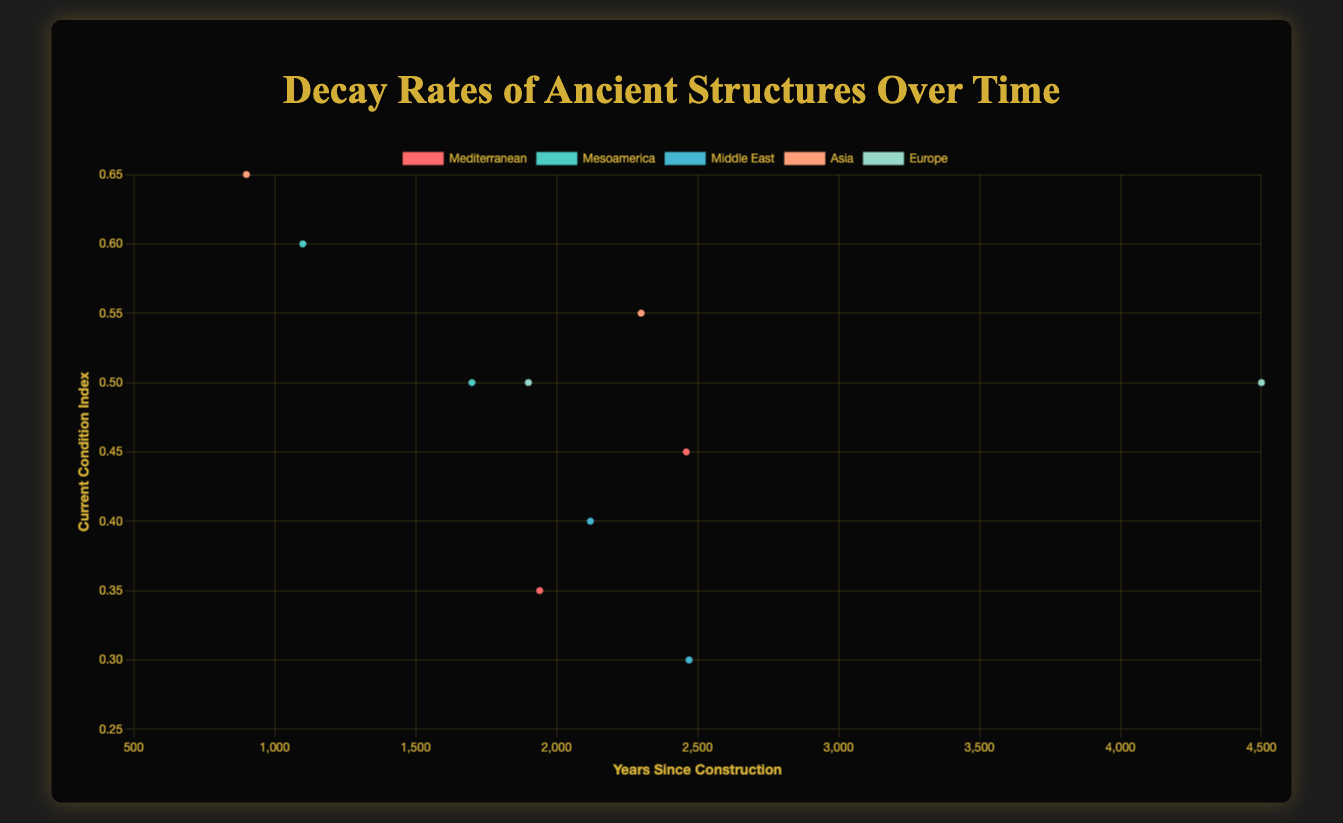Which region shows the lowest current condition index? Look for the region with the lowest value on the y-axis. The lowest condition index is 0.30, associated with Persepolis in the Middle East.
Answer: Middle East Which ancient structure has been standing the longest and what is its current condition index? Identify the data point farthest right on the x-axis, which represents the years since construction. Stonehenge in Europe has been standing for 4500 years with a current condition index of 0.50.
Answer: Stonehenge, 0.50 Which region has the highest average current condition index? Calculate the average condition index for each region by summing the condition indices of the structures within a region and dividing by the number of structures. The values are: Mediterranean (0.40), Mesoamerica (0.55), Middle East (0.35), Asia (0.60), and Europe (0.50). The highest average is in Asia.
Answer: Asia What is the difference in the current condition index between the Great Wall of China and Persepolis? Subtract the current condition index of Persepolis (0.30) from that of the Great Wall of China (0.55). The difference is 0.55 - 0.30 = 0.25.
Answer: 0.25 Is the condition index of Angkor Wat greater than that of Chichen Itza and if so, by how much? Compare the current condition index of Angkor Wat (0.65) with that of Chichen Itza (0.60). The difference is 0.65 - 0.60 = 0.05.
Answer: Yes, by 0.05 How does the current condition index of Parthenon compare to that of Colosseum? Compare the current condition indices of the Parthenon (0.45) and the Colosseum (0.35). The Parthenon has a higher condition index by 0.10.
Answer: Parthenon is higher by 0.10 Which region shows the least variation in current condition indices? Calculate the range (maximum - minimum) of current condition indices within each region. Mediterranean (0.45 - 0.35 = 0.10), Mesoamerica (0.60 - 0.50 = 0.10), Middle East (0.40 - 0.30 = 0.10), Asia (0.65 - 0.55 = 0.10), Europe (0.50 - 0.50 = 0). Europe shows the least variation.
Answer: Europe Which ancient structure in Mesoamerica has a higher condition index? Compare the condition indices of Chichen Itza (0.60) and Teotihuacan (0.50). Chichen Itza has a higher condition index.
Answer: Chichen Itza 